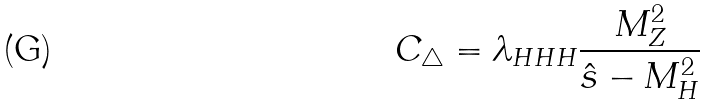Convert formula to latex. <formula><loc_0><loc_0><loc_500><loc_500>C _ { \triangle } = \lambda _ { H H H } \frac { M _ { Z } ^ { 2 } } { \hat { s } - M _ { H } ^ { 2 } }</formula> 